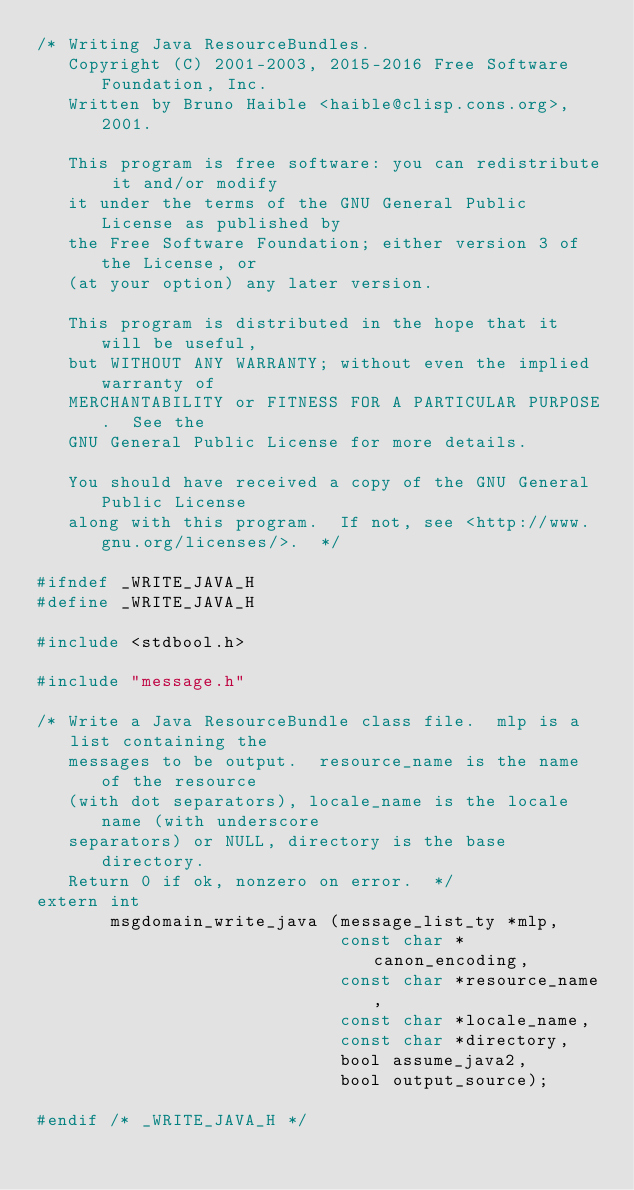Convert code to text. <code><loc_0><loc_0><loc_500><loc_500><_C_>/* Writing Java ResourceBundles.
   Copyright (C) 2001-2003, 2015-2016 Free Software Foundation, Inc.
   Written by Bruno Haible <haible@clisp.cons.org>, 2001.

   This program is free software: you can redistribute it and/or modify
   it under the terms of the GNU General Public License as published by
   the Free Software Foundation; either version 3 of the License, or
   (at your option) any later version.

   This program is distributed in the hope that it will be useful,
   but WITHOUT ANY WARRANTY; without even the implied warranty of
   MERCHANTABILITY or FITNESS FOR A PARTICULAR PURPOSE.  See the
   GNU General Public License for more details.

   You should have received a copy of the GNU General Public License
   along with this program.  If not, see <http://www.gnu.org/licenses/>.  */

#ifndef _WRITE_JAVA_H
#define _WRITE_JAVA_H

#include <stdbool.h>

#include "message.h"

/* Write a Java ResourceBundle class file.  mlp is a list containing the
   messages to be output.  resource_name is the name of the resource
   (with dot separators), locale_name is the locale name (with underscore
   separators) or NULL, directory is the base directory.
   Return 0 if ok, nonzero on error.  */
extern int
       msgdomain_write_java (message_list_ty *mlp,
                             const char *canon_encoding,
                             const char *resource_name,
                             const char *locale_name,
                             const char *directory,
                             bool assume_java2,
                             bool output_source);

#endif /* _WRITE_JAVA_H */
</code> 